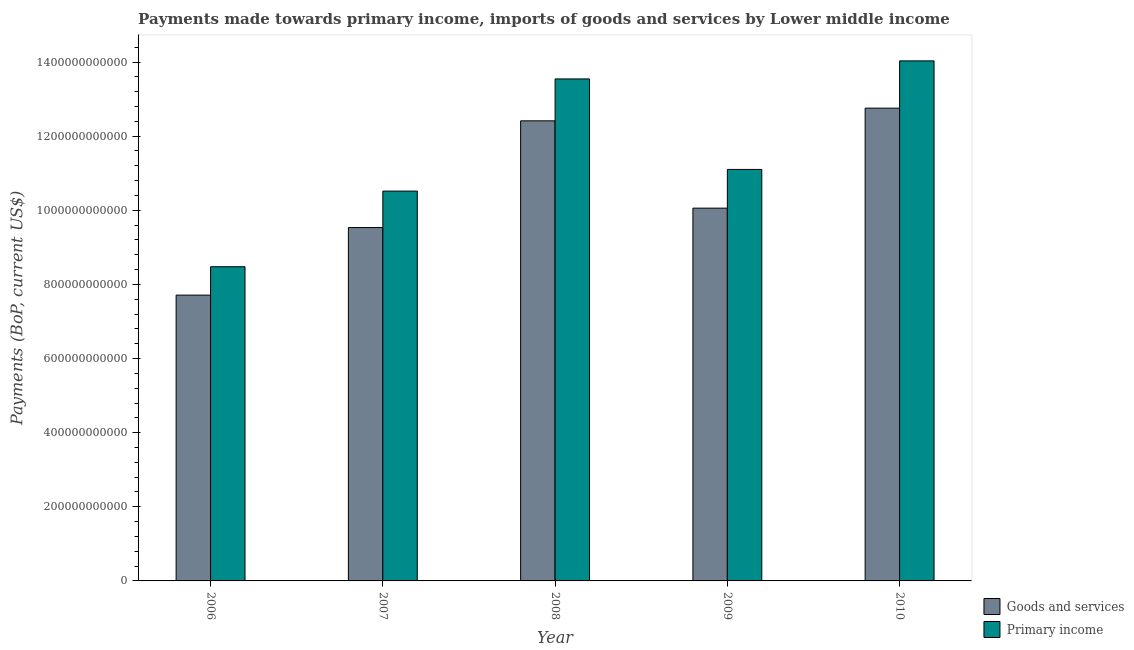How many different coloured bars are there?
Your answer should be very brief. 2. Are the number of bars on each tick of the X-axis equal?
Make the answer very short. Yes. How many bars are there on the 5th tick from the left?
Offer a terse response. 2. How many bars are there on the 1st tick from the right?
Ensure brevity in your answer.  2. What is the label of the 4th group of bars from the left?
Your answer should be very brief. 2009. In how many cases, is the number of bars for a given year not equal to the number of legend labels?
Provide a short and direct response. 0. What is the payments made towards goods and services in 2007?
Keep it short and to the point. 9.53e+11. Across all years, what is the maximum payments made towards goods and services?
Offer a terse response. 1.28e+12. Across all years, what is the minimum payments made towards goods and services?
Provide a succinct answer. 7.71e+11. What is the total payments made towards goods and services in the graph?
Keep it short and to the point. 5.25e+12. What is the difference between the payments made towards primary income in 2007 and that in 2008?
Your answer should be very brief. -3.03e+11. What is the difference between the payments made towards primary income in 2006 and the payments made towards goods and services in 2007?
Provide a succinct answer. -2.04e+11. What is the average payments made towards goods and services per year?
Your response must be concise. 1.05e+12. What is the ratio of the payments made towards primary income in 2006 to that in 2009?
Give a very brief answer. 0.76. Is the payments made towards goods and services in 2007 less than that in 2008?
Provide a succinct answer. Yes. Is the difference between the payments made towards goods and services in 2006 and 2009 greater than the difference between the payments made towards primary income in 2006 and 2009?
Offer a very short reply. No. What is the difference between the highest and the second highest payments made towards goods and services?
Your answer should be compact. 3.43e+1. What is the difference between the highest and the lowest payments made towards goods and services?
Ensure brevity in your answer.  5.04e+11. In how many years, is the payments made towards primary income greater than the average payments made towards primary income taken over all years?
Your answer should be compact. 2. Is the sum of the payments made towards goods and services in 2006 and 2008 greater than the maximum payments made towards primary income across all years?
Offer a very short reply. Yes. What does the 1st bar from the left in 2009 represents?
Give a very brief answer. Goods and services. What does the 2nd bar from the right in 2007 represents?
Ensure brevity in your answer.  Goods and services. How many bars are there?
Offer a very short reply. 10. Are all the bars in the graph horizontal?
Your response must be concise. No. How many years are there in the graph?
Provide a short and direct response. 5. What is the difference between two consecutive major ticks on the Y-axis?
Provide a succinct answer. 2.00e+11. Are the values on the major ticks of Y-axis written in scientific E-notation?
Give a very brief answer. No. Does the graph contain any zero values?
Offer a terse response. No. Does the graph contain grids?
Keep it short and to the point. No. Where does the legend appear in the graph?
Give a very brief answer. Bottom right. How are the legend labels stacked?
Offer a very short reply. Vertical. What is the title of the graph?
Your answer should be compact. Payments made towards primary income, imports of goods and services by Lower middle income. What is the label or title of the Y-axis?
Give a very brief answer. Payments (BoP, current US$). What is the Payments (BoP, current US$) in Goods and services in 2006?
Your response must be concise. 7.71e+11. What is the Payments (BoP, current US$) in Primary income in 2006?
Your answer should be very brief. 8.48e+11. What is the Payments (BoP, current US$) of Goods and services in 2007?
Your answer should be very brief. 9.53e+11. What is the Payments (BoP, current US$) of Primary income in 2007?
Your response must be concise. 1.05e+12. What is the Payments (BoP, current US$) of Goods and services in 2008?
Provide a succinct answer. 1.24e+12. What is the Payments (BoP, current US$) of Primary income in 2008?
Give a very brief answer. 1.35e+12. What is the Payments (BoP, current US$) in Goods and services in 2009?
Provide a succinct answer. 1.01e+12. What is the Payments (BoP, current US$) of Primary income in 2009?
Give a very brief answer. 1.11e+12. What is the Payments (BoP, current US$) of Goods and services in 2010?
Your answer should be very brief. 1.28e+12. What is the Payments (BoP, current US$) of Primary income in 2010?
Your response must be concise. 1.40e+12. Across all years, what is the maximum Payments (BoP, current US$) in Goods and services?
Offer a very short reply. 1.28e+12. Across all years, what is the maximum Payments (BoP, current US$) of Primary income?
Your answer should be very brief. 1.40e+12. Across all years, what is the minimum Payments (BoP, current US$) in Goods and services?
Provide a succinct answer. 7.71e+11. Across all years, what is the minimum Payments (BoP, current US$) of Primary income?
Your answer should be compact. 8.48e+11. What is the total Payments (BoP, current US$) of Goods and services in the graph?
Make the answer very short. 5.25e+12. What is the total Payments (BoP, current US$) of Primary income in the graph?
Your answer should be compact. 5.77e+12. What is the difference between the Payments (BoP, current US$) of Goods and services in 2006 and that in 2007?
Keep it short and to the point. -1.82e+11. What is the difference between the Payments (BoP, current US$) in Primary income in 2006 and that in 2007?
Provide a short and direct response. -2.04e+11. What is the difference between the Payments (BoP, current US$) of Goods and services in 2006 and that in 2008?
Make the answer very short. -4.70e+11. What is the difference between the Payments (BoP, current US$) of Primary income in 2006 and that in 2008?
Your answer should be compact. -5.07e+11. What is the difference between the Payments (BoP, current US$) of Goods and services in 2006 and that in 2009?
Your answer should be compact. -2.35e+11. What is the difference between the Payments (BoP, current US$) in Primary income in 2006 and that in 2009?
Offer a terse response. -2.63e+11. What is the difference between the Payments (BoP, current US$) in Goods and services in 2006 and that in 2010?
Give a very brief answer. -5.04e+11. What is the difference between the Payments (BoP, current US$) in Primary income in 2006 and that in 2010?
Offer a very short reply. -5.55e+11. What is the difference between the Payments (BoP, current US$) of Goods and services in 2007 and that in 2008?
Your answer should be compact. -2.88e+11. What is the difference between the Payments (BoP, current US$) in Primary income in 2007 and that in 2008?
Offer a terse response. -3.03e+11. What is the difference between the Payments (BoP, current US$) in Goods and services in 2007 and that in 2009?
Offer a terse response. -5.24e+1. What is the difference between the Payments (BoP, current US$) of Primary income in 2007 and that in 2009?
Make the answer very short. -5.85e+1. What is the difference between the Payments (BoP, current US$) of Goods and services in 2007 and that in 2010?
Your answer should be very brief. -3.22e+11. What is the difference between the Payments (BoP, current US$) of Primary income in 2007 and that in 2010?
Keep it short and to the point. -3.51e+11. What is the difference between the Payments (BoP, current US$) in Goods and services in 2008 and that in 2009?
Offer a very short reply. 2.36e+11. What is the difference between the Payments (BoP, current US$) of Primary income in 2008 and that in 2009?
Provide a short and direct response. 2.44e+11. What is the difference between the Payments (BoP, current US$) in Goods and services in 2008 and that in 2010?
Give a very brief answer. -3.43e+1. What is the difference between the Payments (BoP, current US$) of Primary income in 2008 and that in 2010?
Offer a terse response. -4.87e+1. What is the difference between the Payments (BoP, current US$) of Goods and services in 2009 and that in 2010?
Provide a short and direct response. -2.70e+11. What is the difference between the Payments (BoP, current US$) in Primary income in 2009 and that in 2010?
Provide a succinct answer. -2.93e+11. What is the difference between the Payments (BoP, current US$) of Goods and services in 2006 and the Payments (BoP, current US$) of Primary income in 2007?
Your response must be concise. -2.81e+11. What is the difference between the Payments (BoP, current US$) in Goods and services in 2006 and the Payments (BoP, current US$) in Primary income in 2008?
Give a very brief answer. -5.83e+11. What is the difference between the Payments (BoP, current US$) of Goods and services in 2006 and the Payments (BoP, current US$) of Primary income in 2009?
Offer a terse response. -3.39e+11. What is the difference between the Payments (BoP, current US$) of Goods and services in 2006 and the Payments (BoP, current US$) of Primary income in 2010?
Provide a succinct answer. -6.32e+11. What is the difference between the Payments (BoP, current US$) of Goods and services in 2007 and the Payments (BoP, current US$) of Primary income in 2008?
Your answer should be compact. -4.01e+11. What is the difference between the Payments (BoP, current US$) of Goods and services in 2007 and the Payments (BoP, current US$) of Primary income in 2009?
Ensure brevity in your answer.  -1.57e+11. What is the difference between the Payments (BoP, current US$) in Goods and services in 2007 and the Payments (BoP, current US$) in Primary income in 2010?
Make the answer very short. -4.50e+11. What is the difference between the Payments (BoP, current US$) in Goods and services in 2008 and the Payments (BoP, current US$) in Primary income in 2009?
Give a very brief answer. 1.31e+11. What is the difference between the Payments (BoP, current US$) of Goods and services in 2008 and the Payments (BoP, current US$) of Primary income in 2010?
Your answer should be compact. -1.62e+11. What is the difference between the Payments (BoP, current US$) in Goods and services in 2009 and the Payments (BoP, current US$) in Primary income in 2010?
Offer a very short reply. -3.97e+11. What is the average Payments (BoP, current US$) of Goods and services per year?
Give a very brief answer. 1.05e+12. What is the average Payments (BoP, current US$) of Primary income per year?
Offer a terse response. 1.15e+12. In the year 2006, what is the difference between the Payments (BoP, current US$) of Goods and services and Payments (BoP, current US$) of Primary income?
Keep it short and to the point. -7.66e+1. In the year 2007, what is the difference between the Payments (BoP, current US$) in Goods and services and Payments (BoP, current US$) in Primary income?
Provide a succinct answer. -9.84e+1. In the year 2008, what is the difference between the Payments (BoP, current US$) in Goods and services and Payments (BoP, current US$) in Primary income?
Give a very brief answer. -1.13e+11. In the year 2009, what is the difference between the Payments (BoP, current US$) in Goods and services and Payments (BoP, current US$) in Primary income?
Provide a succinct answer. -1.04e+11. In the year 2010, what is the difference between the Payments (BoP, current US$) in Goods and services and Payments (BoP, current US$) in Primary income?
Offer a terse response. -1.28e+11. What is the ratio of the Payments (BoP, current US$) in Goods and services in 2006 to that in 2007?
Offer a very short reply. 0.81. What is the ratio of the Payments (BoP, current US$) in Primary income in 2006 to that in 2007?
Provide a succinct answer. 0.81. What is the ratio of the Payments (BoP, current US$) in Goods and services in 2006 to that in 2008?
Your answer should be very brief. 0.62. What is the ratio of the Payments (BoP, current US$) of Primary income in 2006 to that in 2008?
Give a very brief answer. 0.63. What is the ratio of the Payments (BoP, current US$) in Goods and services in 2006 to that in 2009?
Keep it short and to the point. 0.77. What is the ratio of the Payments (BoP, current US$) in Primary income in 2006 to that in 2009?
Offer a terse response. 0.76. What is the ratio of the Payments (BoP, current US$) of Goods and services in 2006 to that in 2010?
Your answer should be very brief. 0.6. What is the ratio of the Payments (BoP, current US$) in Primary income in 2006 to that in 2010?
Make the answer very short. 0.6. What is the ratio of the Payments (BoP, current US$) of Goods and services in 2007 to that in 2008?
Make the answer very short. 0.77. What is the ratio of the Payments (BoP, current US$) in Primary income in 2007 to that in 2008?
Keep it short and to the point. 0.78. What is the ratio of the Payments (BoP, current US$) of Goods and services in 2007 to that in 2009?
Provide a short and direct response. 0.95. What is the ratio of the Payments (BoP, current US$) in Primary income in 2007 to that in 2009?
Your response must be concise. 0.95. What is the ratio of the Payments (BoP, current US$) of Goods and services in 2007 to that in 2010?
Your answer should be compact. 0.75. What is the ratio of the Payments (BoP, current US$) in Primary income in 2007 to that in 2010?
Make the answer very short. 0.75. What is the ratio of the Payments (BoP, current US$) of Goods and services in 2008 to that in 2009?
Provide a short and direct response. 1.23. What is the ratio of the Payments (BoP, current US$) in Primary income in 2008 to that in 2009?
Ensure brevity in your answer.  1.22. What is the ratio of the Payments (BoP, current US$) in Goods and services in 2008 to that in 2010?
Give a very brief answer. 0.97. What is the ratio of the Payments (BoP, current US$) of Primary income in 2008 to that in 2010?
Provide a succinct answer. 0.97. What is the ratio of the Payments (BoP, current US$) in Goods and services in 2009 to that in 2010?
Provide a succinct answer. 0.79. What is the ratio of the Payments (BoP, current US$) of Primary income in 2009 to that in 2010?
Your response must be concise. 0.79. What is the difference between the highest and the second highest Payments (BoP, current US$) of Goods and services?
Provide a short and direct response. 3.43e+1. What is the difference between the highest and the second highest Payments (BoP, current US$) in Primary income?
Your answer should be compact. 4.87e+1. What is the difference between the highest and the lowest Payments (BoP, current US$) of Goods and services?
Ensure brevity in your answer.  5.04e+11. What is the difference between the highest and the lowest Payments (BoP, current US$) in Primary income?
Offer a very short reply. 5.55e+11. 